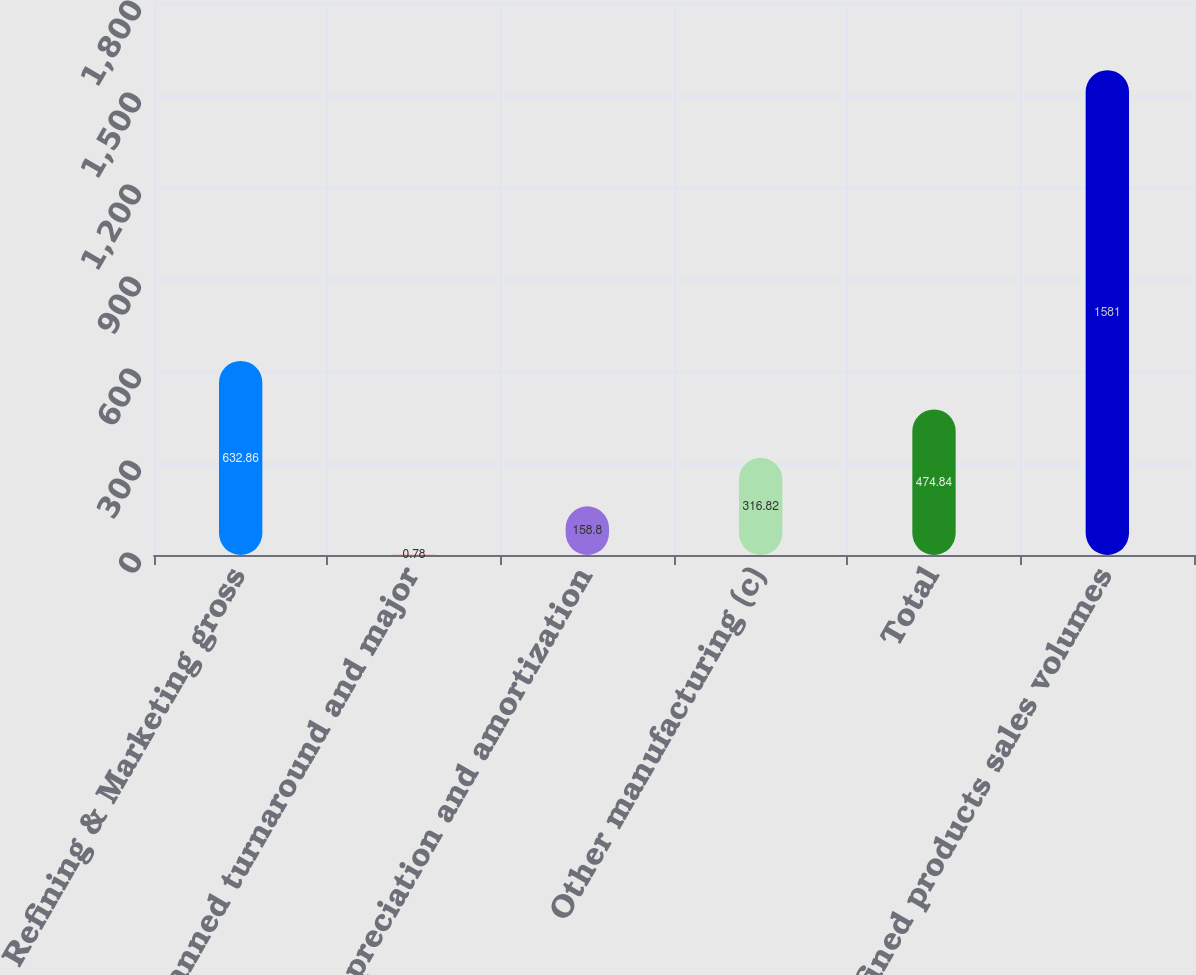Convert chart to OTSL. <chart><loc_0><loc_0><loc_500><loc_500><bar_chart><fcel>Refining & Marketing gross<fcel>Planned turnaround and major<fcel>Depreciation and amortization<fcel>Other manufacturing (c)<fcel>Total<fcel>Refined products sales volumes<nl><fcel>632.86<fcel>0.78<fcel>158.8<fcel>316.82<fcel>474.84<fcel>1581<nl></chart> 